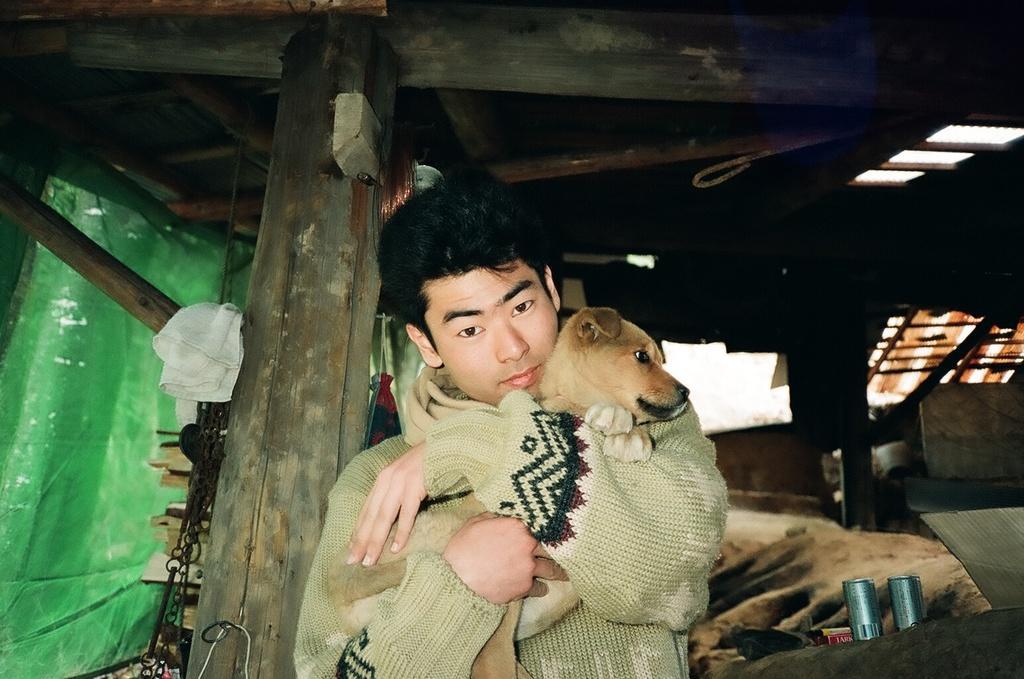Describe this image in one or two sentences. A guy who is wearing a sweatshirt is holding a brown dog and he is inside a wooden house. In the background there is a green color curtain and to the right side of him there are two tins. 